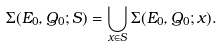<formula> <loc_0><loc_0><loc_500><loc_500>\Sigma ( E _ { 0 } , Q _ { 0 } ; S ) = \bigcup _ { x \in S } \Sigma ( E _ { 0 } , Q _ { 0 } ; x ) .</formula> 